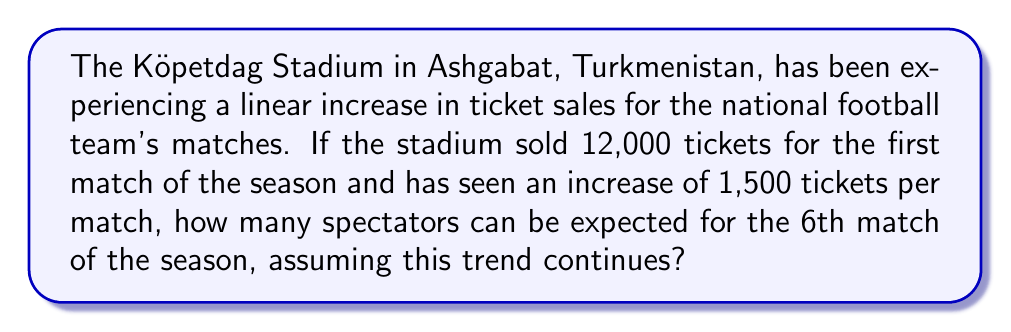What is the answer to this math problem? Let's approach this step-by-step using a linear equation:

1) Let $y$ represent the number of tickets sold and $x$ represent the match number.

2) We can express this situation with the linear equation:
   $y = mx + b$
   Where $m$ is the slope (rate of increase) and $b$ is the y-intercept (initial ticket sales).

3) We know:
   - Initial ticket sales (b) = 12,000
   - Rate of increase (m) = 1,500 tickets per match
   - We want to find ticket sales for the 6th match (x = 6)

4) Plugging these values into our equation:
   $y = 1500x + 12000$

5) To find the ticket sales for the 6th match, we substitute x = 6:
   $y = 1500(6) + 12000$
   $y = 9000 + 12000$
   $y = 21000$

Therefore, based on this linear trend, we can expect 21,000 spectators for the 6th match of the season.
Answer: 21,000 spectators 